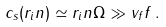Convert formula to latex. <formula><loc_0><loc_0><loc_500><loc_500>c _ { s } ( r _ { i } n ) \simeq r _ { i } n \Omega \gg v _ { f } f \, .</formula> 